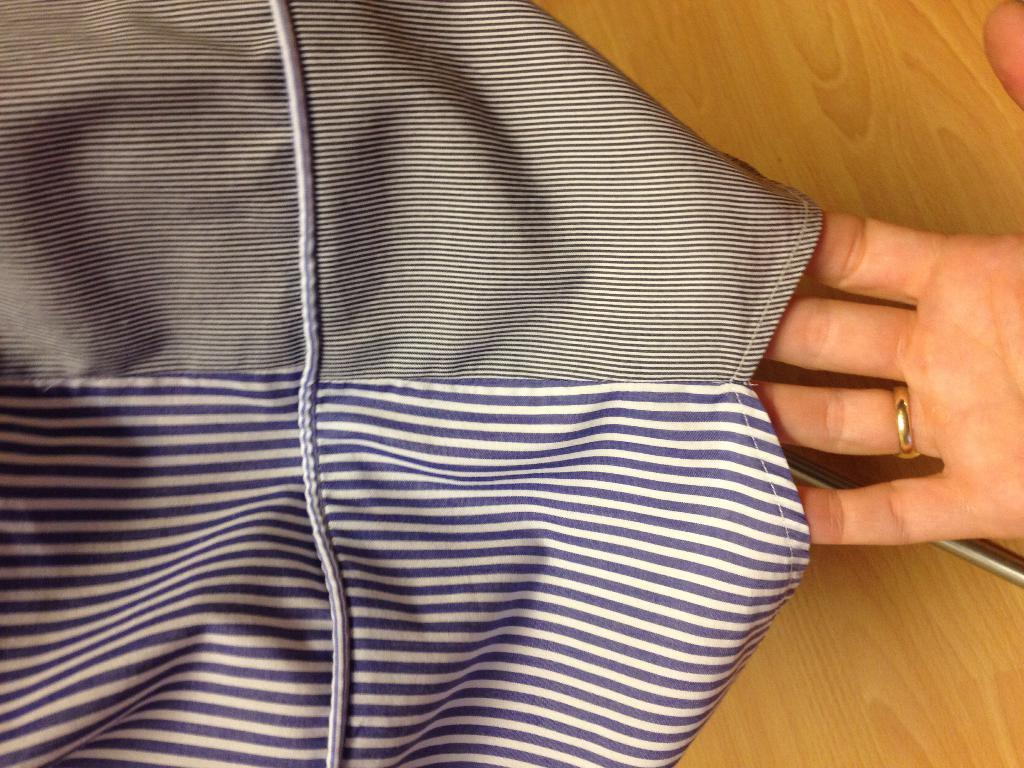What object is present in the image that is made of fabric? There is a cloth in the image. Whose hand is visible in the image? A person's hand is visible in the image. What type of jewelry is worn by the person in the image? There is a golden-colored ring on the person's finger. What type of steel object is being used to carry water in the image? There is no steel object or water-carrying activity present in the image. 